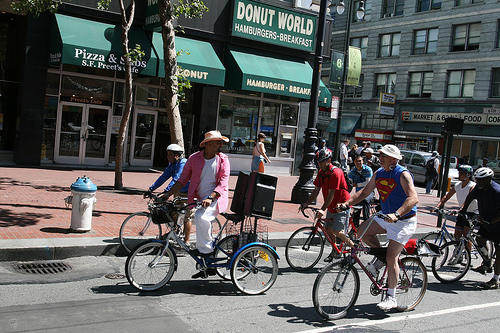<image>
Can you confirm if the woman is on the bicycle? No. The woman is not positioned on the bicycle. They may be near each other, but the woman is not supported by or resting on top of the bicycle. 